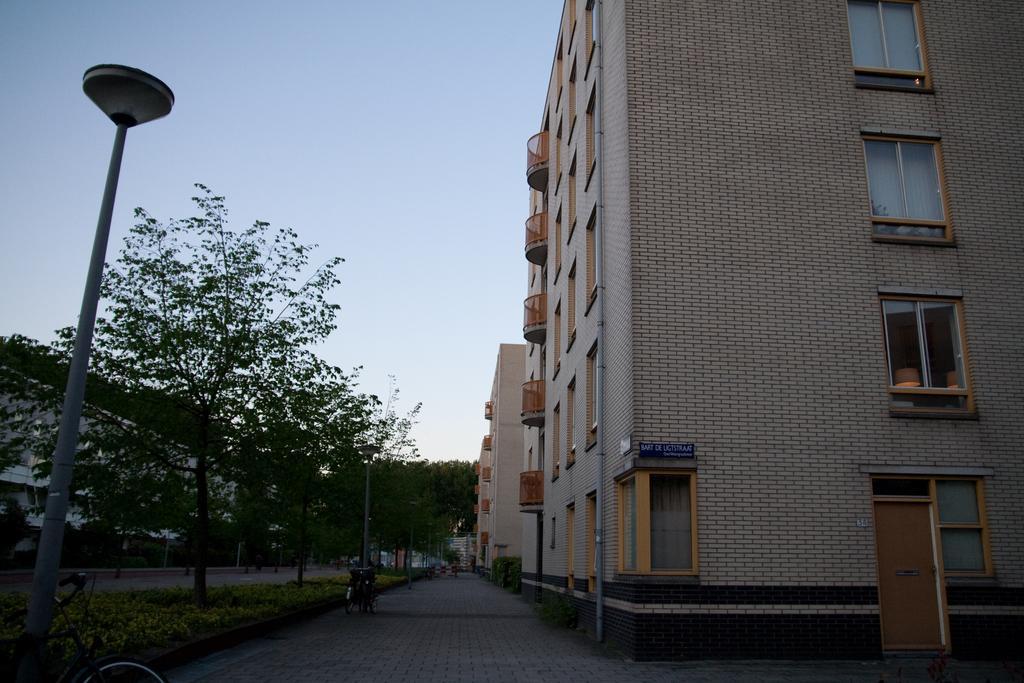In one or two sentences, can you explain what this image depicts? In this image we can see buildings with windows and door. To the left side of the image there are trees, light pole. At the top of the image there is sky. At the bottom of the image there is a pavement. To the left side of the image there are plants. There is a bicycle. 